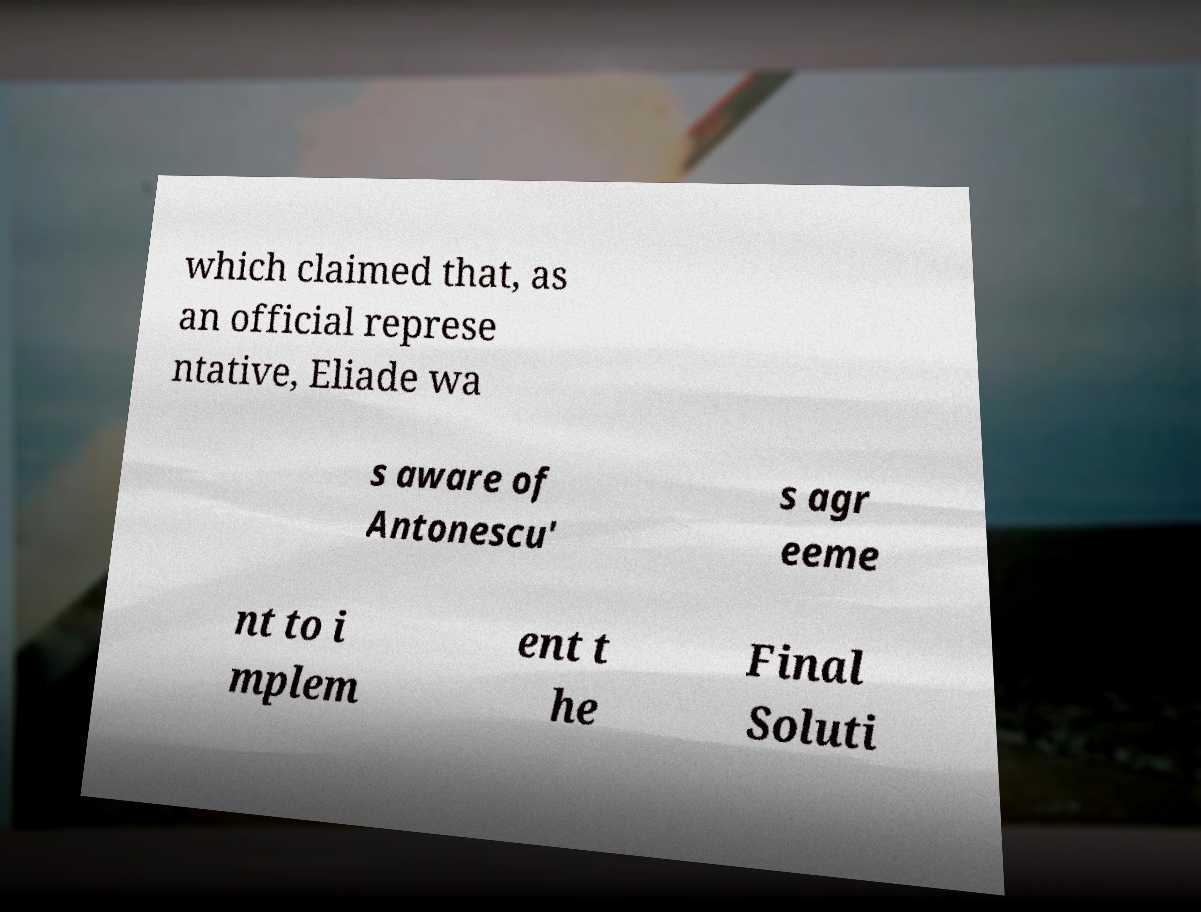What messages or text are displayed in this image? I need them in a readable, typed format. which claimed that, as an official represe ntative, Eliade wa s aware of Antonescu' s agr eeme nt to i mplem ent t he Final Soluti 